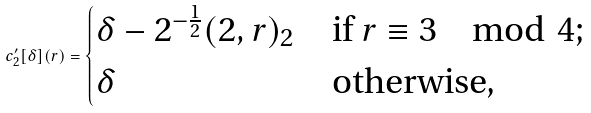<formula> <loc_0><loc_0><loc_500><loc_500>c ^ { \prime } _ { 2 } [ \delta ] ( r ) = \begin{cases} \delta - 2 ^ { - \frac { 1 } { 2 } } ( 2 , r ) _ { 2 } & \text {if } r \equiv 3 \mod 4 ; \\ \delta & \text {otherwise,} \\ \end{cases}</formula> 